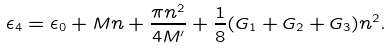<formula> <loc_0><loc_0><loc_500><loc_500>\epsilon _ { 4 } = \epsilon _ { 0 } + M n + \frac { \pi n ^ { 2 } } { 4 M ^ { \prime } } + \frac { 1 } { 8 } ( G _ { 1 } + G _ { 2 } + G _ { 3 } ) n ^ { 2 } .</formula> 